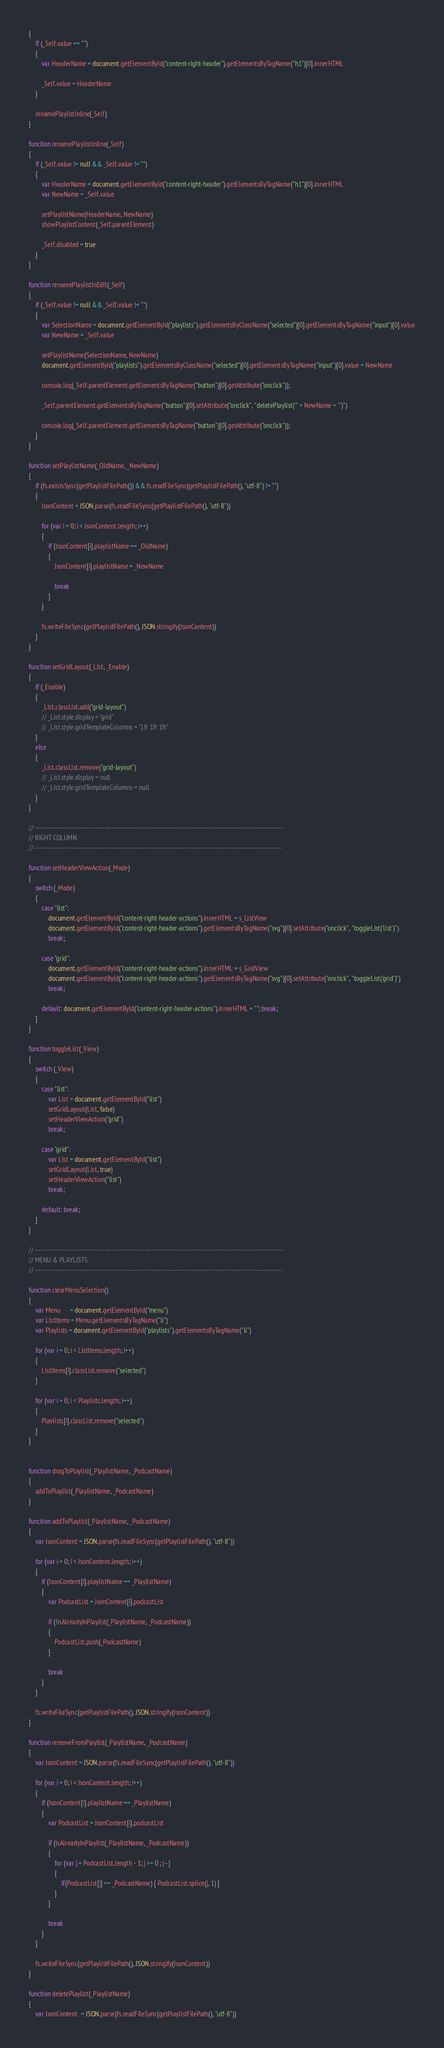<code> <loc_0><loc_0><loc_500><loc_500><_JavaScript_>{
    if (_Self.value == "")
    {
        var HeaderName = document.getElementById("content-right-header").getElementsByTagName("h1")[0].innerHTML

        _Self.value = HeaderName
    }

    renamePlaylistInline(_Self)
}

function renamePlaylistInline(_Self)
{
    if (_Self.value != null && _Self.value != "")
    {
        var HeaderName = document.getElementById("content-right-header").getElementsByTagName("h1")[0].innerHTML
        var NewName = _Self.value

        setPlaylistName(HeaderName, NewName)
        showPlaylistContent(_Self.parentElement)

        _Self.disabled = true
    }
}

function renamePlaylistInEdit(_Self)
{
    if (_Self.value != null && _Self.value != "")
    {
        var SelectionName = document.getElementById("playlists").getElementsByClassName("selected")[0].getElementsByTagName("input")[0].value
        var NewName = _Self.value

        setPlaylistName(SelectionName, NewName)
        document.getElementById("playlists").getElementsByClassName("selected")[0].getElementsByTagName("input")[0].value = NewName

        console.log(_Self.parentElement.getElementsByTagName("button")[0].getAttribute("onclick"));

        _Self.parentElement.getElementsByTagName("button")[0].setAttribute("onclick", "deletePlaylist('" + NewName + "')")

        console.log(_Self.parentElement.getElementsByTagName("button")[0].getAttribute("onclick"));
    }
}

function setPlaylistName(_OldName, _NewName)
{
    if (fs.existsSync(getPlaylistFilePath()) && fs.readFileSync(getPlaylistFilePath(), "utf-8") != "")
    {
        JsonContent = JSON.parse(fs.readFileSync(getPlaylistFilePath(), "utf-8"))

        for (var i = 0; i < JsonContent.length; i++)
        {
            if (JsonContent[i].playlistName == _OldName)
            {
                JsonContent[i].playlistName = _NewName

                break
            }
        }

        fs.writeFileSync(getPlaylistFilePath(), JSON.stringify(JsonContent))
    }
}

function setGridLayout(_List, _Enable)
{
    if (_Enable)
    {
        _List.classList.add("grid-layout")
        // _List.style.display = "grid"
        // _List.style.gridTemplateColumns = "1fr 1fr 1fr"
    }
    else
    {
        _List.classList.remove("grid-layout")
        // _List.style.display = null
        // _List.style.gridTemplateColumns = null
    }
}

// ---------------------------------------------------------------------------------------------------------------------
// RIGHT COLUMN
// ---------------------------------------------------------------------------------------------------------------------

function setHeaderViewAction(_Mode)
{
    switch (_Mode)
    {
        case "list":
            document.getElementById("content-right-header-actions").innerHTML = s_ListView
            document.getElementById("content-right-header-actions").getElementsByTagName("svg")[0].setAttribute("onclick", "toggleList('list')")
            break;

        case "grid":
            document.getElementById("content-right-header-actions").innerHTML = s_GridView
            document.getElementById("content-right-header-actions").getElementsByTagName("svg")[0].setAttribute("onclick", "toggleList('grid')")
            break;

        default: document.getElementById("content-right-header-actions").innerHTML = ""; break;
    }
}

function toggleList(_View)
{
    switch (_View)
    {
        case "list":
            var List = document.getElementById("list")
            setGridLayout(List, false)
            setHeaderViewAction("grid")
            break;

        case "grid":
            var List = document.getElementById("list")
            setGridLayout(List, true)
            setHeaderViewAction("list")
            break;

        default: break;
    }
}

// ---------------------------------------------------------------------------------------------------------------------
// MENU & PLAYLISTS
// ---------------------------------------------------------------------------------------------------------------------

function clearMenuSelection()
{
    var Menu      = document.getElementById("menu")
    var ListItems = Menu.getElementsByTagName("li")
    var Playlists = document.getElementById("playlists").getElementsByTagName("li")

    for (var i = 0; i < ListItems.length; i++)
    {
        ListItems[i].classList.remove("selected")
    }

    for (var i = 0; i < Playlists.length; i++)
    {
        Playlists[i].classList.remove("selected")
    }
}


function dragToPlaylist(_PlaylistName, _PodcastName)
{
    addToPlaylist(_PlaylistName, _PodcastName)
}

function addToPlaylist(_PlaylistName, _PodcastName)
{
    var JsonContent = JSON.parse(fs.readFileSync(getPlaylistFilePath(), "utf-8"))

    for (var i = 0; i < JsonContent.length; i++)
    {
        if (JsonContent[i].playlistName == _PlaylistName)
        {
            var PodcastList = JsonContent[i].podcastList

            if (!isAlreadyInPlaylist(_PlaylistName, _PodcastName))
            {
                PodcastList.push(_PodcastName)
            }

            break
        }
    }

    fs.writeFileSync(getPlaylistFilePath(), JSON.stringify(JsonContent))
}

function removeFromPlaylist(_PlaylistName, _PodcastName)
{
    var JsonContent = JSON.parse(fs.readFileSync(getPlaylistFilePath(), "utf-8"))

    for (var i = 0; i < JsonContent.length; i++)
    {
        if (JsonContent[i].playlistName == _PlaylistName)
        {
            var PodcastList = JsonContent[i].podcastList

            if (isAlreadyInPlaylist(_PlaylistName, _PodcastName))
            {
                for (var j = PodcastList.length - 1; j >= 0 ; j--)
                {
                    if(PodcastList[j] == _PodcastName) { PodcastList.splice(j, 1) }
                }
            }

            break
        }
    }

    fs.writeFileSync(getPlaylistFilePath(), JSON.stringify(JsonContent))
}

function deletePlaylist(_PlaylistName)
{
    var JsonContent  = JSON.parse(fs.readFileSync(getPlaylistFilePath(), "utf-8"))
</code> 